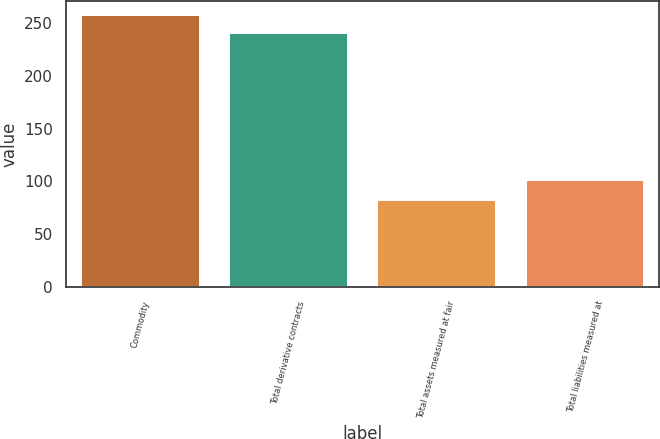Convert chart. <chart><loc_0><loc_0><loc_500><loc_500><bar_chart><fcel>Commodity<fcel>Total derivative contracts<fcel>Total assets measured at fair<fcel>Total liabilities measured at<nl><fcel>258.2<fcel>241<fcel>82<fcel>101<nl></chart> 